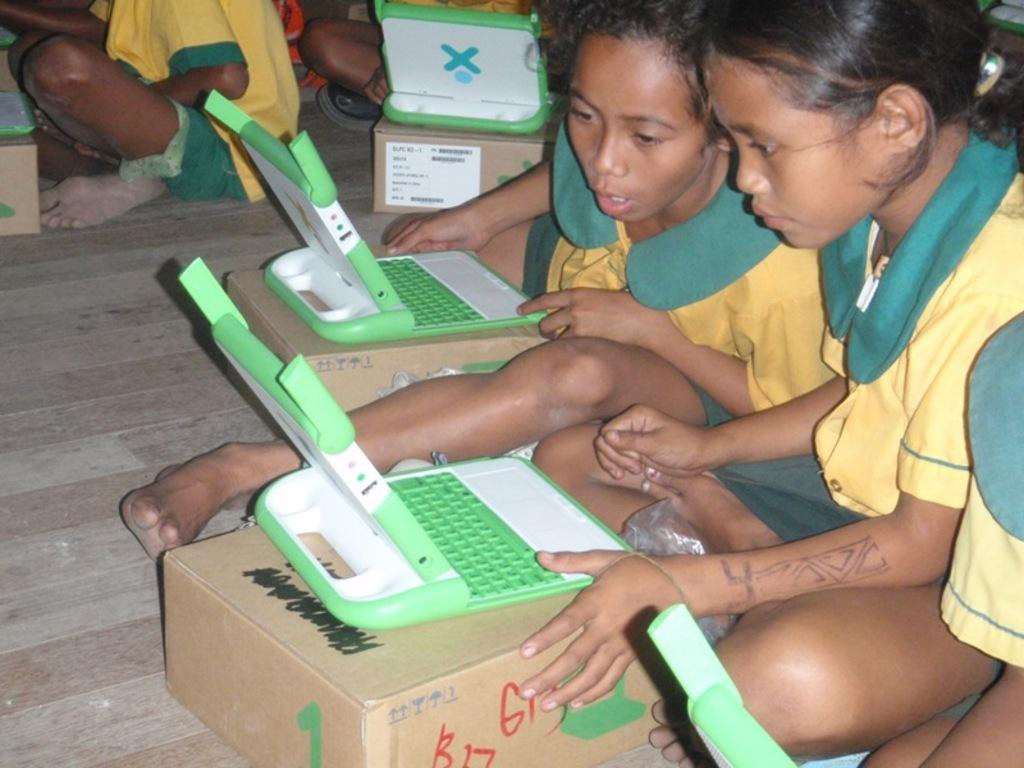What are the children sitting on in the image? The children are sitting on a wooden surface. What can be seen in front of the children? There are toys on boxes in front of the children. What is the material of the surface at the bottom of the image? The wooden surface at the bottom of the image is made of wood. What type of locket is hanging from the chin of one of the children in the image? There is no locket hanging from the chin of any of the children in the image. 